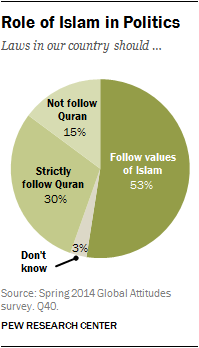Point out several critical features in this image. The total value of the three smallest segments combined is less than the value of the largest segment. The smallest segment is of a gray color. 